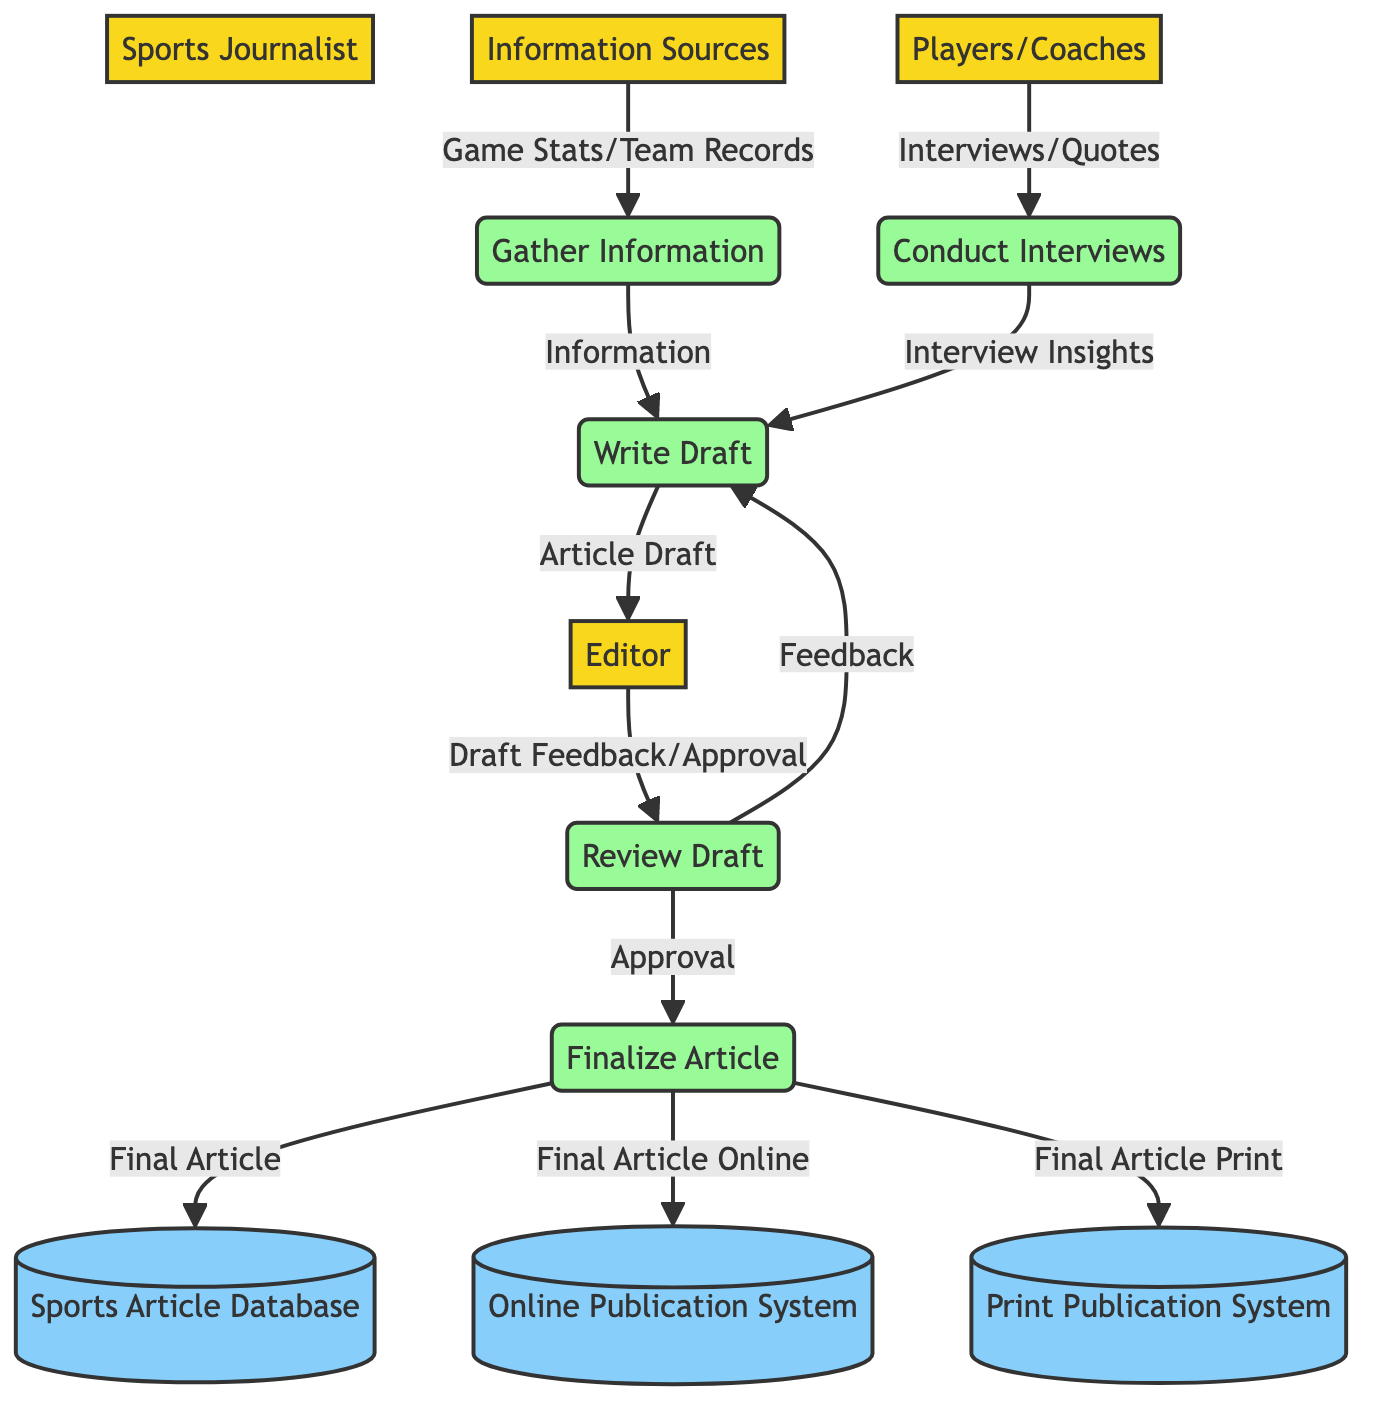What is the primary role of the Sports Journalist in this workflow? The Sports Journalist is responsible for creating the article by gathering information, conducting interviews, writing drafts, and finalizing the article for publication.
Answer: Creating the article How many external entities are in this diagram? There are five external entities: Sports Journalist, Information Sources, Players/Coaches, Editor, and Publication Systems.
Answer: Five What type of information does the Sports Journalist gather? The Sports Journalist gathers game statistics, team records, and other relevant information from Information Sources.
Answer: Game statistics, team records Which process comes after the "Conduct Interviews" process? The process that follows "Conduct Interviews" is "Write Draft", where the journalist compiles information and insights into an article draft.
Answer: Write Draft What feedback does the Editor provide to the Draft? The Editor provides feedback or approval on the article draft before it is finalized.
Answer: Draft Feedback/Approval What are the outputs of the "Finalize Article" process? The outputs of the "Finalize Article" process include the finalized article sent to the Sports Article Database, Online Publication System, and Print Publication System.
Answer: Sports Article Database, Online Publication System, Print Publication System In the data flow between "Review Draft" and "Write Draft," what does the Editor provide? The Editor provides feedback to the Write Draft process, which is necessary for revisions before finalizing the article.
Answer: Feedback What do the Information Sources contribute to the workflow? The Information Sources contribute game statistics and team records to the "Gather Information" process, which are crucial for writing the article.
Answer: Game Stats/Team Records What signifies the completion of the article creation process? The completion is signified by the output of the "Finalize Article" process, which sends the final article to relevant publication systems and the database.
Answer: Final Article 